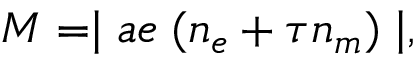Convert formula to latex. <formula><loc_0><loc_0><loc_500><loc_500>M = | a e \, ( n _ { e } + \tau n _ { m } ) | ,</formula> 